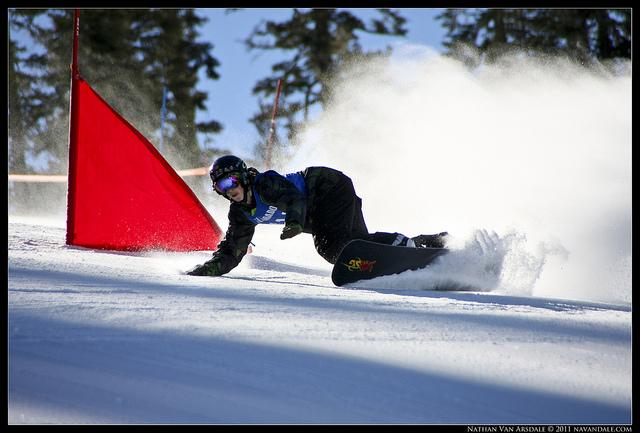Is this a sport?
Write a very short answer. Yes. What color is the flag behind the snowboarder?
Concise answer only. Red. Do you see snow?
Write a very short answer. Yes. 